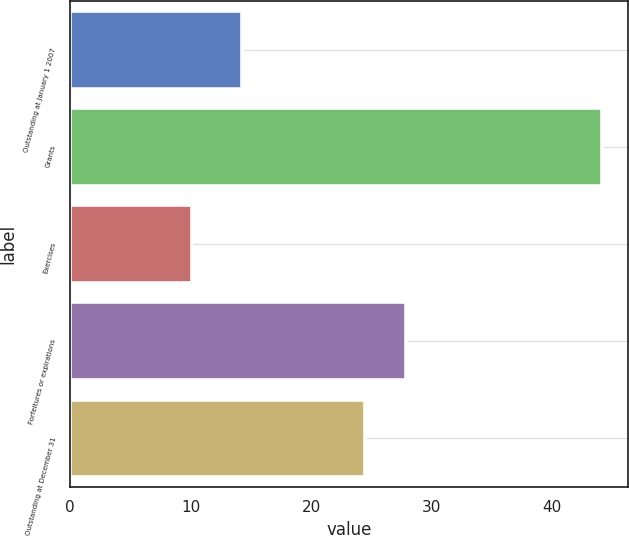Convert chart. <chart><loc_0><loc_0><loc_500><loc_500><bar_chart><fcel>Outstanding at January 1 2007<fcel>Grants<fcel>Exercises<fcel>Forfeitures or expirations<fcel>Outstanding at December 31<nl><fcel>14.24<fcel>44.09<fcel>10.08<fcel>27.84<fcel>24.44<nl></chart> 